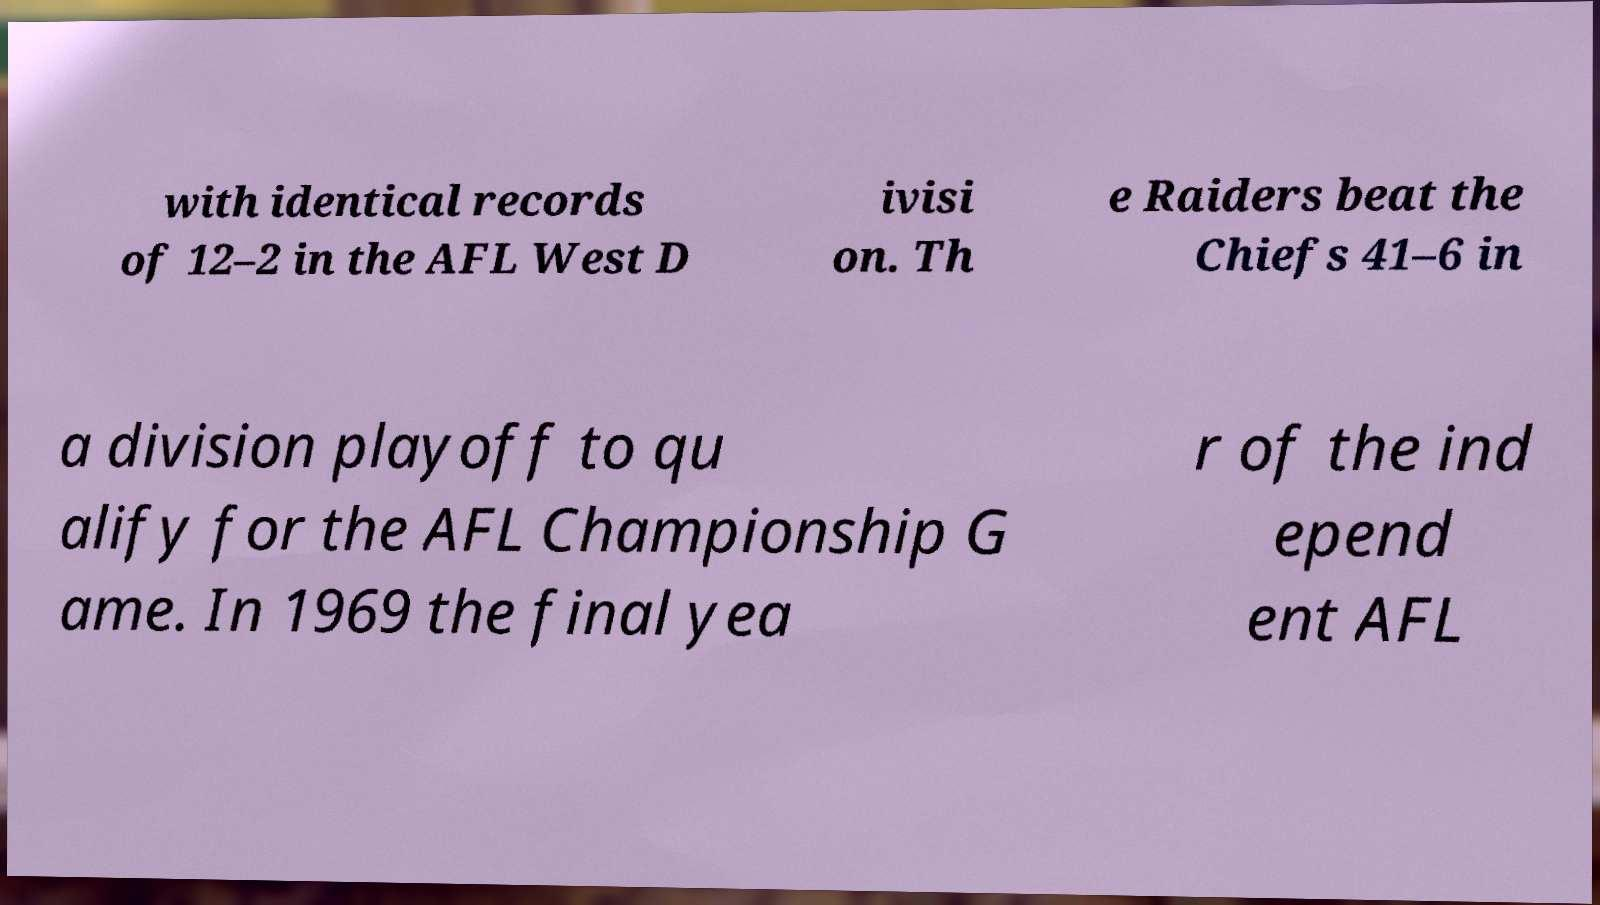Could you assist in decoding the text presented in this image and type it out clearly? with identical records of 12–2 in the AFL West D ivisi on. Th e Raiders beat the Chiefs 41–6 in a division playoff to qu alify for the AFL Championship G ame. In 1969 the final yea r of the ind epend ent AFL 